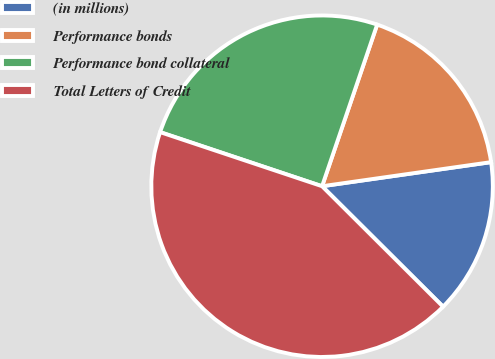Convert chart to OTSL. <chart><loc_0><loc_0><loc_500><loc_500><pie_chart><fcel>(in millions)<fcel>Performance bonds<fcel>Performance bond collateral<fcel>Total Letters of Credit<nl><fcel>14.72%<fcel>17.52%<fcel>25.1%<fcel>42.67%<nl></chart> 